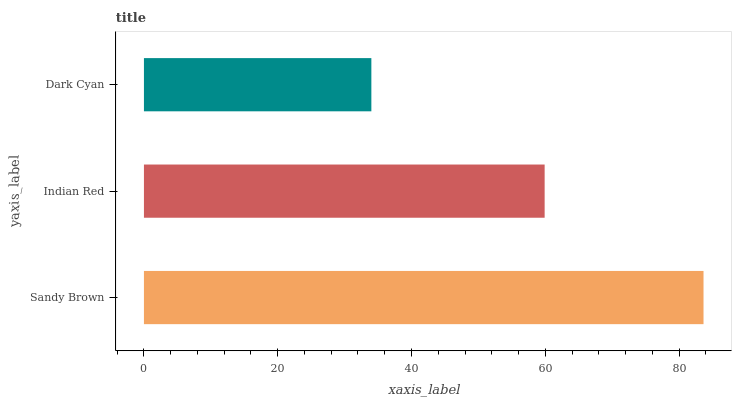Is Dark Cyan the minimum?
Answer yes or no. Yes. Is Sandy Brown the maximum?
Answer yes or no. Yes. Is Indian Red the minimum?
Answer yes or no. No. Is Indian Red the maximum?
Answer yes or no. No. Is Sandy Brown greater than Indian Red?
Answer yes or no. Yes. Is Indian Red less than Sandy Brown?
Answer yes or no. Yes. Is Indian Red greater than Sandy Brown?
Answer yes or no. No. Is Sandy Brown less than Indian Red?
Answer yes or no. No. Is Indian Red the high median?
Answer yes or no. Yes. Is Indian Red the low median?
Answer yes or no. Yes. Is Dark Cyan the high median?
Answer yes or no. No. Is Sandy Brown the low median?
Answer yes or no. No. 